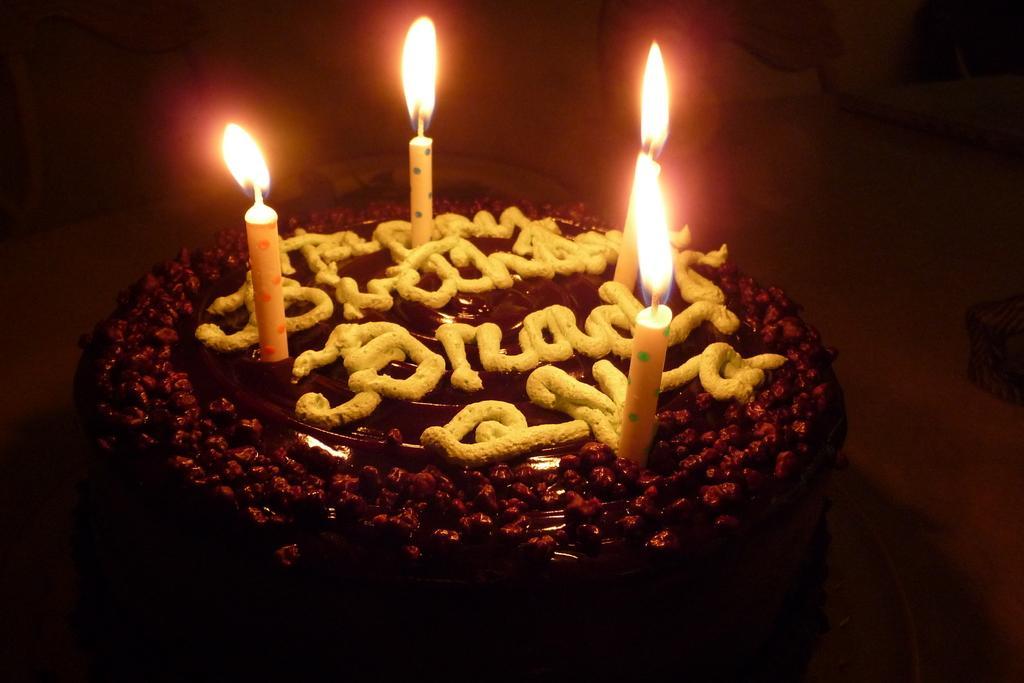Could you give a brief overview of what you see in this image? In the image we can see a cake and four candles on the cake. The corners of the image are blurred. 